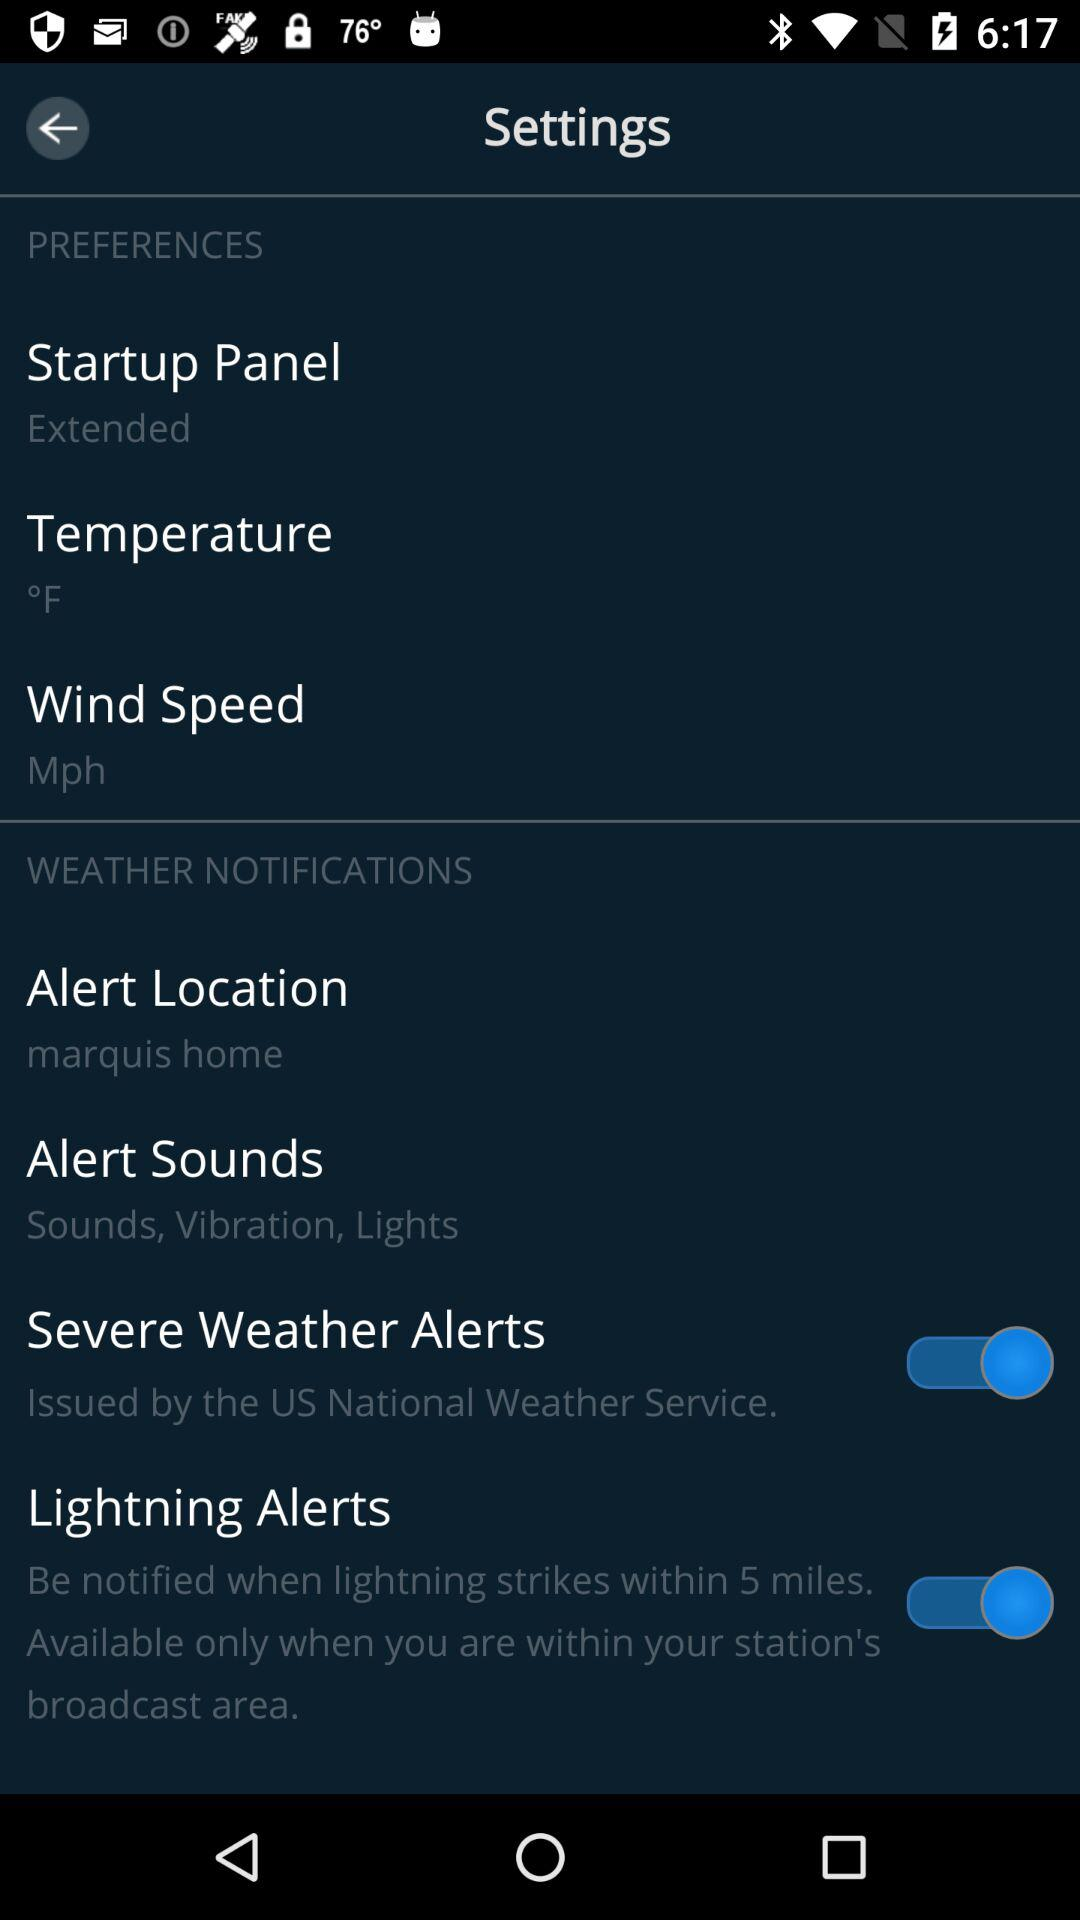What is the selected unit of wind speed? The selected unit of wind speed is mph. 